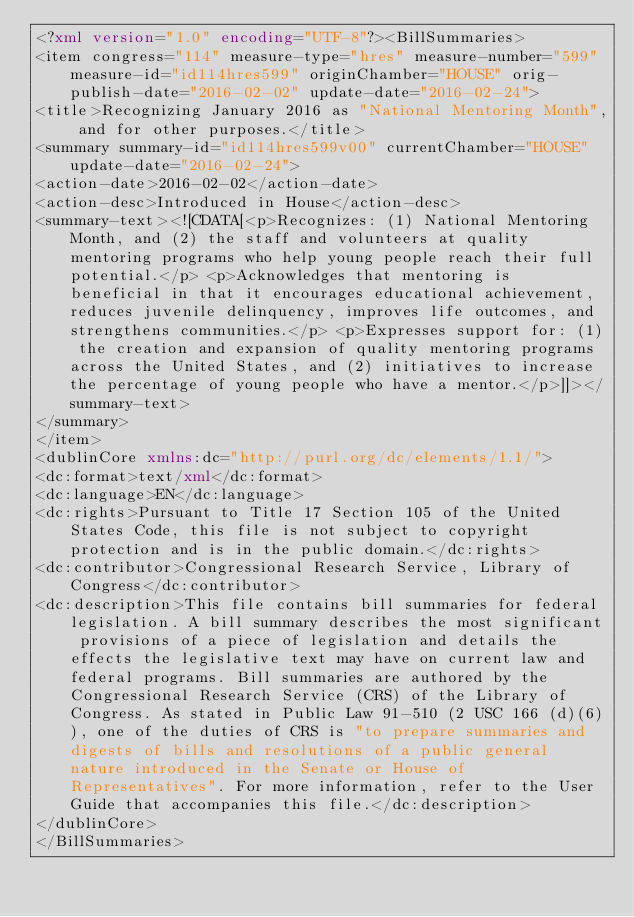Convert code to text. <code><loc_0><loc_0><loc_500><loc_500><_XML_><?xml version="1.0" encoding="UTF-8"?><BillSummaries>
<item congress="114" measure-type="hres" measure-number="599" measure-id="id114hres599" originChamber="HOUSE" orig-publish-date="2016-02-02" update-date="2016-02-24">
<title>Recognizing January 2016 as "National Mentoring Month", and for other purposes.</title>
<summary summary-id="id114hres599v00" currentChamber="HOUSE" update-date="2016-02-24">
<action-date>2016-02-02</action-date>
<action-desc>Introduced in House</action-desc>
<summary-text><![CDATA[<p>Recognizes: (1) National Mentoring Month, and (2) the staff and volunteers at quality mentoring programs who help young people reach their full potential.</p> <p>Acknowledges that mentoring is beneficial in that it encourages educational achievement, reduces juvenile delinquency, improves life outcomes, and strengthens communities.</p> <p>Expresses support for: (1) the creation and expansion of quality mentoring programs across the United States, and (2) initiatives to increase the percentage of young people who have a mentor.</p>]]></summary-text>
</summary>
</item>
<dublinCore xmlns:dc="http://purl.org/dc/elements/1.1/">
<dc:format>text/xml</dc:format>
<dc:language>EN</dc:language>
<dc:rights>Pursuant to Title 17 Section 105 of the United States Code, this file is not subject to copyright protection and is in the public domain.</dc:rights>
<dc:contributor>Congressional Research Service, Library of Congress</dc:contributor>
<dc:description>This file contains bill summaries for federal legislation. A bill summary describes the most significant provisions of a piece of legislation and details the effects the legislative text may have on current law and federal programs. Bill summaries are authored by the Congressional Research Service (CRS) of the Library of Congress. As stated in Public Law 91-510 (2 USC 166 (d)(6)), one of the duties of CRS is "to prepare summaries and digests of bills and resolutions of a public general nature introduced in the Senate or House of Representatives". For more information, refer to the User Guide that accompanies this file.</dc:description>
</dublinCore>
</BillSummaries>
</code> 